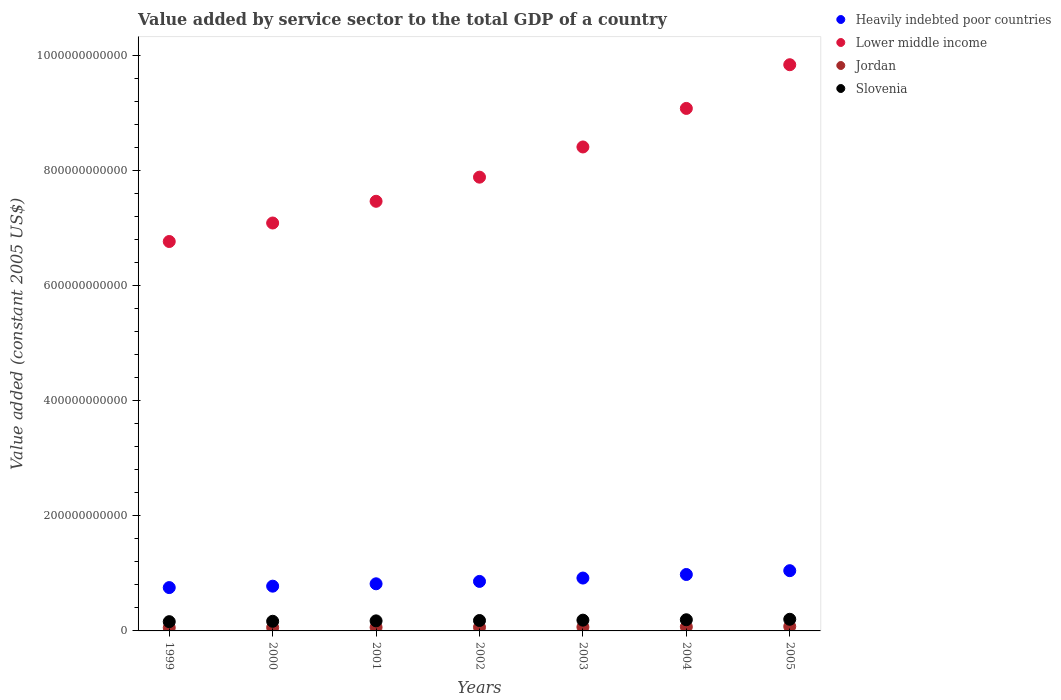What is the value added by service sector in Lower middle income in 2001?
Your response must be concise. 7.46e+11. Across all years, what is the maximum value added by service sector in Jordan?
Provide a short and direct response. 7.67e+09. Across all years, what is the minimum value added by service sector in Jordan?
Make the answer very short. 5.62e+09. In which year was the value added by service sector in Slovenia minimum?
Your answer should be very brief. 1999. What is the total value added by service sector in Jordan in the graph?
Your answer should be compact. 4.54e+1. What is the difference between the value added by service sector in Lower middle income in 1999 and that in 2003?
Provide a short and direct response. -1.64e+11. What is the difference between the value added by service sector in Slovenia in 2004 and the value added by service sector in Heavily indebted poor countries in 2000?
Provide a succinct answer. -5.84e+1. What is the average value added by service sector in Heavily indebted poor countries per year?
Ensure brevity in your answer.  8.79e+1. In the year 1999, what is the difference between the value added by service sector in Jordan and value added by service sector in Lower middle income?
Provide a succinct answer. -6.71e+11. What is the ratio of the value added by service sector in Jordan in 2000 to that in 2004?
Ensure brevity in your answer.  0.83. Is the difference between the value added by service sector in Jordan in 2002 and 2005 greater than the difference between the value added by service sector in Lower middle income in 2002 and 2005?
Keep it short and to the point. Yes. What is the difference between the highest and the second highest value added by service sector in Heavily indebted poor countries?
Offer a terse response. 6.63e+09. What is the difference between the highest and the lowest value added by service sector in Jordan?
Make the answer very short. 2.05e+09. In how many years, is the value added by service sector in Heavily indebted poor countries greater than the average value added by service sector in Heavily indebted poor countries taken over all years?
Your response must be concise. 3. Does the value added by service sector in Slovenia monotonically increase over the years?
Make the answer very short. Yes. Is the value added by service sector in Lower middle income strictly less than the value added by service sector in Slovenia over the years?
Your answer should be compact. No. How many years are there in the graph?
Your answer should be compact. 7. What is the difference between two consecutive major ticks on the Y-axis?
Provide a succinct answer. 2.00e+11. Are the values on the major ticks of Y-axis written in scientific E-notation?
Provide a short and direct response. No. Does the graph contain grids?
Offer a very short reply. No. How many legend labels are there?
Offer a very short reply. 4. How are the legend labels stacked?
Give a very brief answer. Vertical. What is the title of the graph?
Your answer should be compact. Value added by service sector to the total GDP of a country. What is the label or title of the X-axis?
Keep it short and to the point. Years. What is the label or title of the Y-axis?
Your response must be concise. Value added (constant 2005 US$). What is the Value added (constant 2005 US$) of Heavily indebted poor countries in 1999?
Your answer should be very brief. 7.53e+1. What is the Value added (constant 2005 US$) in Lower middle income in 1999?
Your answer should be compact. 6.77e+11. What is the Value added (constant 2005 US$) of Jordan in 1999?
Keep it short and to the point. 5.62e+09. What is the Value added (constant 2005 US$) in Slovenia in 1999?
Make the answer very short. 1.61e+1. What is the Value added (constant 2005 US$) in Heavily indebted poor countries in 2000?
Ensure brevity in your answer.  7.78e+1. What is the Value added (constant 2005 US$) in Lower middle income in 2000?
Keep it short and to the point. 7.09e+11. What is the Value added (constant 2005 US$) in Jordan in 2000?
Offer a very short reply. 5.90e+09. What is the Value added (constant 2005 US$) in Slovenia in 2000?
Provide a short and direct response. 1.68e+1. What is the Value added (constant 2005 US$) in Heavily indebted poor countries in 2001?
Offer a terse response. 8.19e+1. What is the Value added (constant 2005 US$) in Lower middle income in 2001?
Your answer should be very brief. 7.46e+11. What is the Value added (constant 2005 US$) of Jordan in 2001?
Your response must be concise. 6.19e+09. What is the Value added (constant 2005 US$) in Slovenia in 2001?
Your answer should be very brief. 1.75e+1. What is the Value added (constant 2005 US$) in Heavily indebted poor countries in 2002?
Your response must be concise. 8.60e+1. What is the Value added (constant 2005 US$) in Lower middle income in 2002?
Your answer should be compact. 7.88e+11. What is the Value added (constant 2005 US$) in Jordan in 2002?
Offer a very short reply. 6.33e+09. What is the Value added (constant 2005 US$) of Slovenia in 2002?
Make the answer very short. 1.81e+1. What is the Value added (constant 2005 US$) in Heavily indebted poor countries in 2003?
Ensure brevity in your answer.  9.19e+1. What is the Value added (constant 2005 US$) in Lower middle income in 2003?
Keep it short and to the point. 8.41e+11. What is the Value added (constant 2005 US$) in Jordan in 2003?
Offer a terse response. 6.64e+09. What is the Value added (constant 2005 US$) of Slovenia in 2003?
Your response must be concise. 1.87e+1. What is the Value added (constant 2005 US$) in Heavily indebted poor countries in 2004?
Your answer should be very brief. 9.80e+1. What is the Value added (constant 2005 US$) in Lower middle income in 2004?
Offer a very short reply. 9.08e+11. What is the Value added (constant 2005 US$) of Jordan in 2004?
Your answer should be very brief. 7.09e+09. What is the Value added (constant 2005 US$) of Slovenia in 2004?
Your response must be concise. 1.94e+1. What is the Value added (constant 2005 US$) of Heavily indebted poor countries in 2005?
Your answer should be compact. 1.05e+11. What is the Value added (constant 2005 US$) of Lower middle income in 2005?
Provide a short and direct response. 9.84e+11. What is the Value added (constant 2005 US$) of Jordan in 2005?
Offer a very short reply. 7.67e+09. What is the Value added (constant 2005 US$) of Slovenia in 2005?
Provide a short and direct response. 2.02e+1. Across all years, what is the maximum Value added (constant 2005 US$) in Heavily indebted poor countries?
Ensure brevity in your answer.  1.05e+11. Across all years, what is the maximum Value added (constant 2005 US$) of Lower middle income?
Your answer should be compact. 9.84e+11. Across all years, what is the maximum Value added (constant 2005 US$) in Jordan?
Ensure brevity in your answer.  7.67e+09. Across all years, what is the maximum Value added (constant 2005 US$) of Slovenia?
Provide a succinct answer. 2.02e+1. Across all years, what is the minimum Value added (constant 2005 US$) of Heavily indebted poor countries?
Offer a terse response. 7.53e+1. Across all years, what is the minimum Value added (constant 2005 US$) of Lower middle income?
Give a very brief answer. 6.77e+11. Across all years, what is the minimum Value added (constant 2005 US$) of Jordan?
Offer a terse response. 5.62e+09. Across all years, what is the minimum Value added (constant 2005 US$) of Slovenia?
Make the answer very short. 1.61e+1. What is the total Value added (constant 2005 US$) in Heavily indebted poor countries in the graph?
Ensure brevity in your answer.  6.15e+11. What is the total Value added (constant 2005 US$) of Lower middle income in the graph?
Ensure brevity in your answer.  5.65e+12. What is the total Value added (constant 2005 US$) of Jordan in the graph?
Your answer should be compact. 4.54e+1. What is the total Value added (constant 2005 US$) in Slovenia in the graph?
Provide a succinct answer. 1.27e+11. What is the difference between the Value added (constant 2005 US$) of Heavily indebted poor countries in 1999 and that in 2000?
Offer a very short reply. -2.46e+09. What is the difference between the Value added (constant 2005 US$) of Lower middle income in 1999 and that in 2000?
Provide a short and direct response. -3.21e+1. What is the difference between the Value added (constant 2005 US$) of Jordan in 1999 and that in 2000?
Provide a short and direct response. -2.83e+08. What is the difference between the Value added (constant 2005 US$) of Slovenia in 1999 and that in 2000?
Provide a short and direct response. -6.56e+08. What is the difference between the Value added (constant 2005 US$) of Heavily indebted poor countries in 1999 and that in 2001?
Provide a short and direct response. -6.57e+09. What is the difference between the Value added (constant 2005 US$) in Lower middle income in 1999 and that in 2001?
Your answer should be compact. -6.99e+1. What is the difference between the Value added (constant 2005 US$) in Jordan in 1999 and that in 2001?
Offer a very short reply. -5.71e+08. What is the difference between the Value added (constant 2005 US$) in Slovenia in 1999 and that in 2001?
Provide a succinct answer. -1.37e+09. What is the difference between the Value added (constant 2005 US$) in Heavily indebted poor countries in 1999 and that in 2002?
Provide a short and direct response. -1.07e+1. What is the difference between the Value added (constant 2005 US$) in Lower middle income in 1999 and that in 2002?
Ensure brevity in your answer.  -1.12e+11. What is the difference between the Value added (constant 2005 US$) of Jordan in 1999 and that in 2002?
Your answer should be compact. -7.13e+08. What is the difference between the Value added (constant 2005 US$) of Slovenia in 1999 and that in 2002?
Keep it short and to the point. -1.99e+09. What is the difference between the Value added (constant 2005 US$) in Heavily indebted poor countries in 1999 and that in 2003?
Offer a very short reply. -1.66e+1. What is the difference between the Value added (constant 2005 US$) of Lower middle income in 1999 and that in 2003?
Your response must be concise. -1.64e+11. What is the difference between the Value added (constant 2005 US$) in Jordan in 1999 and that in 2003?
Offer a very short reply. -1.03e+09. What is the difference between the Value added (constant 2005 US$) in Slovenia in 1999 and that in 2003?
Give a very brief answer. -2.61e+09. What is the difference between the Value added (constant 2005 US$) in Heavily indebted poor countries in 1999 and that in 2004?
Make the answer very short. -2.27e+1. What is the difference between the Value added (constant 2005 US$) of Lower middle income in 1999 and that in 2004?
Give a very brief answer. -2.31e+11. What is the difference between the Value added (constant 2005 US$) in Jordan in 1999 and that in 2004?
Ensure brevity in your answer.  -1.47e+09. What is the difference between the Value added (constant 2005 US$) in Slovenia in 1999 and that in 2004?
Make the answer very short. -3.30e+09. What is the difference between the Value added (constant 2005 US$) in Heavily indebted poor countries in 1999 and that in 2005?
Give a very brief answer. -2.94e+1. What is the difference between the Value added (constant 2005 US$) of Lower middle income in 1999 and that in 2005?
Make the answer very short. -3.07e+11. What is the difference between the Value added (constant 2005 US$) in Jordan in 1999 and that in 2005?
Give a very brief answer. -2.05e+09. What is the difference between the Value added (constant 2005 US$) of Slovenia in 1999 and that in 2005?
Ensure brevity in your answer.  -4.13e+09. What is the difference between the Value added (constant 2005 US$) in Heavily indebted poor countries in 2000 and that in 2001?
Make the answer very short. -4.12e+09. What is the difference between the Value added (constant 2005 US$) of Lower middle income in 2000 and that in 2001?
Provide a succinct answer. -3.77e+1. What is the difference between the Value added (constant 2005 US$) of Jordan in 2000 and that in 2001?
Provide a short and direct response. -2.88e+08. What is the difference between the Value added (constant 2005 US$) of Slovenia in 2000 and that in 2001?
Your response must be concise. -7.09e+08. What is the difference between the Value added (constant 2005 US$) in Heavily indebted poor countries in 2000 and that in 2002?
Keep it short and to the point. -8.27e+09. What is the difference between the Value added (constant 2005 US$) of Lower middle income in 2000 and that in 2002?
Provide a short and direct response. -7.96e+1. What is the difference between the Value added (constant 2005 US$) of Jordan in 2000 and that in 2002?
Provide a short and direct response. -4.30e+08. What is the difference between the Value added (constant 2005 US$) of Slovenia in 2000 and that in 2002?
Your answer should be compact. -1.33e+09. What is the difference between the Value added (constant 2005 US$) in Heavily indebted poor countries in 2000 and that in 2003?
Make the answer very short. -1.41e+1. What is the difference between the Value added (constant 2005 US$) in Lower middle income in 2000 and that in 2003?
Keep it short and to the point. -1.32e+11. What is the difference between the Value added (constant 2005 US$) of Jordan in 2000 and that in 2003?
Offer a very short reply. -7.44e+08. What is the difference between the Value added (constant 2005 US$) in Slovenia in 2000 and that in 2003?
Your answer should be compact. -1.95e+09. What is the difference between the Value added (constant 2005 US$) in Heavily indebted poor countries in 2000 and that in 2004?
Offer a very short reply. -2.03e+1. What is the difference between the Value added (constant 2005 US$) of Lower middle income in 2000 and that in 2004?
Offer a terse response. -1.99e+11. What is the difference between the Value added (constant 2005 US$) in Jordan in 2000 and that in 2004?
Your answer should be very brief. -1.19e+09. What is the difference between the Value added (constant 2005 US$) in Slovenia in 2000 and that in 2004?
Ensure brevity in your answer.  -2.65e+09. What is the difference between the Value added (constant 2005 US$) of Heavily indebted poor countries in 2000 and that in 2005?
Your response must be concise. -2.69e+1. What is the difference between the Value added (constant 2005 US$) of Lower middle income in 2000 and that in 2005?
Keep it short and to the point. -2.75e+11. What is the difference between the Value added (constant 2005 US$) of Jordan in 2000 and that in 2005?
Your answer should be very brief. -1.77e+09. What is the difference between the Value added (constant 2005 US$) of Slovenia in 2000 and that in 2005?
Provide a succinct answer. -3.47e+09. What is the difference between the Value added (constant 2005 US$) of Heavily indebted poor countries in 2001 and that in 2002?
Your answer should be compact. -4.15e+09. What is the difference between the Value added (constant 2005 US$) of Lower middle income in 2001 and that in 2002?
Offer a very short reply. -4.19e+1. What is the difference between the Value added (constant 2005 US$) of Jordan in 2001 and that in 2002?
Your answer should be very brief. -1.42e+08. What is the difference between the Value added (constant 2005 US$) of Slovenia in 2001 and that in 2002?
Your response must be concise. -6.23e+08. What is the difference between the Value added (constant 2005 US$) in Heavily indebted poor countries in 2001 and that in 2003?
Your response must be concise. -9.98e+09. What is the difference between the Value added (constant 2005 US$) of Lower middle income in 2001 and that in 2003?
Make the answer very short. -9.44e+1. What is the difference between the Value added (constant 2005 US$) in Jordan in 2001 and that in 2003?
Offer a very short reply. -4.56e+08. What is the difference between the Value added (constant 2005 US$) in Slovenia in 2001 and that in 2003?
Provide a succinct answer. -1.24e+09. What is the difference between the Value added (constant 2005 US$) in Heavily indebted poor countries in 2001 and that in 2004?
Provide a succinct answer. -1.62e+1. What is the difference between the Value added (constant 2005 US$) of Lower middle income in 2001 and that in 2004?
Ensure brevity in your answer.  -1.61e+11. What is the difference between the Value added (constant 2005 US$) in Jordan in 2001 and that in 2004?
Your response must be concise. -8.99e+08. What is the difference between the Value added (constant 2005 US$) of Slovenia in 2001 and that in 2004?
Provide a short and direct response. -1.94e+09. What is the difference between the Value added (constant 2005 US$) in Heavily indebted poor countries in 2001 and that in 2005?
Your answer should be compact. -2.28e+1. What is the difference between the Value added (constant 2005 US$) of Lower middle income in 2001 and that in 2005?
Make the answer very short. -2.37e+11. What is the difference between the Value added (constant 2005 US$) in Jordan in 2001 and that in 2005?
Provide a succinct answer. -1.48e+09. What is the difference between the Value added (constant 2005 US$) of Slovenia in 2001 and that in 2005?
Your answer should be very brief. -2.76e+09. What is the difference between the Value added (constant 2005 US$) in Heavily indebted poor countries in 2002 and that in 2003?
Provide a short and direct response. -5.83e+09. What is the difference between the Value added (constant 2005 US$) of Lower middle income in 2002 and that in 2003?
Offer a very short reply. -5.25e+1. What is the difference between the Value added (constant 2005 US$) of Jordan in 2002 and that in 2003?
Give a very brief answer. -3.14e+08. What is the difference between the Value added (constant 2005 US$) in Slovenia in 2002 and that in 2003?
Keep it short and to the point. -6.22e+08. What is the difference between the Value added (constant 2005 US$) of Heavily indebted poor countries in 2002 and that in 2004?
Provide a short and direct response. -1.20e+1. What is the difference between the Value added (constant 2005 US$) of Lower middle income in 2002 and that in 2004?
Provide a succinct answer. -1.19e+11. What is the difference between the Value added (constant 2005 US$) of Jordan in 2002 and that in 2004?
Give a very brief answer. -7.56e+08. What is the difference between the Value added (constant 2005 US$) of Slovenia in 2002 and that in 2004?
Your answer should be very brief. -1.32e+09. What is the difference between the Value added (constant 2005 US$) of Heavily indebted poor countries in 2002 and that in 2005?
Provide a succinct answer. -1.86e+1. What is the difference between the Value added (constant 2005 US$) in Lower middle income in 2002 and that in 2005?
Ensure brevity in your answer.  -1.95e+11. What is the difference between the Value added (constant 2005 US$) in Jordan in 2002 and that in 2005?
Ensure brevity in your answer.  -1.34e+09. What is the difference between the Value added (constant 2005 US$) of Slovenia in 2002 and that in 2005?
Provide a succinct answer. -2.14e+09. What is the difference between the Value added (constant 2005 US$) in Heavily indebted poor countries in 2003 and that in 2004?
Offer a very short reply. -6.18e+09. What is the difference between the Value added (constant 2005 US$) in Lower middle income in 2003 and that in 2004?
Keep it short and to the point. -6.70e+1. What is the difference between the Value added (constant 2005 US$) of Jordan in 2003 and that in 2004?
Ensure brevity in your answer.  -4.42e+08. What is the difference between the Value added (constant 2005 US$) of Slovenia in 2003 and that in 2004?
Ensure brevity in your answer.  -6.94e+08. What is the difference between the Value added (constant 2005 US$) of Heavily indebted poor countries in 2003 and that in 2005?
Ensure brevity in your answer.  -1.28e+1. What is the difference between the Value added (constant 2005 US$) in Lower middle income in 2003 and that in 2005?
Provide a short and direct response. -1.43e+11. What is the difference between the Value added (constant 2005 US$) in Jordan in 2003 and that in 2005?
Your answer should be very brief. -1.03e+09. What is the difference between the Value added (constant 2005 US$) in Slovenia in 2003 and that in 2005?
Your answer should be very brief. -1.52e+09. What is the difference between the Value added (constant 2005 US$) in Heavily indebted poor countries in 2004 and that in 2005?
Offer a very short reply. -6.63e+09. What is the difference between the Value added (constant 2005 US$) in Lower middle income in 2004 and that in 2005?
Offer a very short reply. -7.59e+1. What is the difference between the Value added (constant 2005 US$) in Jordan in 2004 and that in 2005?
Give a very brief answer. -5.85e+08. What is the difference between the Value added (constant 2005 US$) in Slovenia in 2004 and that in 2005?
Provide a succinct answer. -8.23e+08. What is the difference between the Value added (constant 2005 US$) in Heavily indebted poor countries in 1999 and the Value added (constant 2005 US$) in Lower middle income in 2000?
Your answer should be very brief. -6.33e+11. What is the difference between the Value added (constant 2005 US$) in Heavily indebted poor countries in 1999 and the Value added (constant 2005 US$) in Jordan in 2000?
Offer a terse response. 6.94e+1. What is the difference between the Value added (constant 2005 US$) of Heavily indebted poor countries in 1999 and the Value added (constant 2005 US$) of Slovenia in 2000?
Ensure brevity in your answer.  5.85e+1. What is the difference between the Value added (constant 2005 US$) in Lower middle income in 1999 and the Value added (constant 2005 US$) in Jordan in 2000?
Give a very brief answer. 6.71e+11. What is the difference between the Value added (constant 2005 US$) of Lower middle income in 1999 and the Value added (constant 2005 US$) of Slovenia in 2000?
Your response must be concise. 6.60e+11. What is the difference between the Value added (constant 2005 US$) in Jordan in 1999 and the Value added (constant 2005 US$) in Slovenia in 2000?
Provide a succinct answer. -1.11e+1. What is the difference between the Value added (constant 2005 US$) in Heavily indebted poor countries in 1999 and the Value added (constant 2005 US$) in Lower middle income in 2001?
Your answer should be very brief. -6.71e+11. What is the difference between the Value added (constant 2005 US$) of Heavily indebted poor countries in 1999 and the Value added (constant 2005 US$) of Jordan in 2001?
Ensure brevity in your answer.  6.91e+1. What is the difference between the Value added (constant 2005 US$) of Heavily indebted poor countries in 1999 and the Value added (constant 2005 US$) of Slovenia in 2001?
Offer a very short reply. 5.78e+1. What is the difference between the Value added (constant 2005 US$) in Lower middle income in 1999 and the Value added (constant 2005 US$) in Jordan in 2001?
Ensure brevity in your answer.  6.70e+11. What is the difference between the Value added (constant 2005 US$) of Lower middle income in 1999 and the Value added (constant 2005 US$) of Slovenia in 2001?
Keep it short and to the point. 6.59e+11. What is the difference between the Value added (constant 2005 US$) of Jordan in 1999 and the Value added (constant 2005 US$) of Slovenia in 2001?
Your response must be concise. -1.18e+1. What is the difference between the Value added (constant 2005 US$) in Heavily indebted poor countries in 1999 and the Value added (constant 2005 US$) in Lower middle income in 2002?
Give a very brief answer. -7.13e+11. What is the difference between the Value added (constant 2005 US$) in Heavily indebted poor countries in 1999 and the Value added (constant 2005 US$) in Jordan in 2002?
Give a very brief answer. 6.90e+1. What is the difference between the Value added (constant 2005 US$) of Heavily indebted poor countries in 1999 and the Value added (constant 2005 US$) of Slovenia in 2002?
Give a very brief answer. 5.72e+1. What is the difference between the Value added (constant 2005 US$) of Lower middle income in 1999 and the Value added (constant 2005 US$) of Jordan in 2002?
Offer a terse response. 6.70e+11. What is the difference between the Value added (constant 2005 US$) in Lower middle income in 1999 and the Value added (constant 2005 US$) in Slovenia in 2002?
Give a very brief answer. 6.58e+11. What is the difference between the Value added (constant 2005 US$) of Jordan in 1999 and the Value added (constant 2005 US$) of Slovenia in 2002?
Your answer should be compact. -1.25e+1. What is the difference between the Value added (constant 2005 US$) of Heavily indebted poor countries in 1999 and the Value added (constant 2005 US$) of Lower middle income in 2003?
Your answer should be very brief. -7.66e+11. What is the difference between the Value added (constant 2005 US$) in Heavily indebted poor countries in 1999 and the Value added (constant 2005 US$) in Jordan in 2003?
Ensure brevity in your answer.  6.87e+1. What is the difference between the Value added (constant 2005 US$) in Heavily indebted poor countries in 1999 and the Value added (constant 2005 US$) in Slovenia in 2003?
Offer a terse response. 5.66e+1. What is the difference between the Value added (constant 2005 US$) of Lower middle income in 1999 and the Value added (constant 2005 US$) of Jordan in 2003?
Offer a terse response. 6.70e+11. What is the difference between the Value added (constant 2005 US$) of Lower middle income in 1999 and the Value added (constant 2005 US$) of Slovenia in 2003?
Offer a very short reply. 6.58e+11. What is the difference between the Value added (constant 2005 US$) of Jordan in 1999 and the Value added (constant 2005 US$) of Slovenia in 2003?
Your answer should be very brief. -1.31e+1. What is the difference between the Value added (constant 2005 US$) in Heavily indebted poor countries in 1999 and the Value added (constant 2005 US$) in Lower middle income in 2004?
Ensure brevity in your answer.  -8.32e+11. What is the difference between the Value added (constant 2005 US$) in Heavily indebted poor countries in 1999 and the Value added (constant 2005 US$) in Jordan in 2004?
Your answer should be very brief. 6.82e+1. What is the difference between the Value added (constant 2005 US$) of Heavily indebted poor countries in 1999 and the Value added (constant 2005 US$) of Slovenia in 2004?
Offer a terse response. 5.59e+1. What is the difference between the Value added (constant 2005 US$) of Lower middle income in 1999 and the Value added (constant 2005 US$) of Jordan in 2004?
Your answer should be compact. 6.69e+11. What is the difference between the Value added (constant 2005 US$) of Lower middle income in 1999 and the Value added (constant 2005 US$) of Slovenia in 2004?
Provide a short and direct response. 6.57e+11. What is the difference between the Value added (constant 2005 US$) of Jordan in 1999 and the Value added (constant 2005 US$) of Slovenia in 2004?
Provide a short and direct response. -1.38e+1. What is the difference between the Value added (constant 2005 US$) of Heavily indebted poor countries in 1999 and the Value added (constant 2005 US$) of Lower middle income in 2005?
Provide a short and direct response. -9.08e+11. What is the difference between the Value added (constant 2005 US$) in Heavily indebted poor countries in 1999 and the Value added (constant 2005 US$) in Jordan in 2005?
Provide a short and direct response. 6.76e+1. What is the difference between the Value added (constant 2005 US$) in Heavily indebted poor countries in 1999 and the Value added (constant 2005 US$) in Slovenia in 2005?
Offer a terse response. 5.51e+1. What is the difference between the Value added (constant 2005 US$) of Lower middle income in 1999 and the Value added (constant 2005 US$) of Jordan in 2005?
Keep it short and to the point. 6.69e+11. What is the difference between the Value added (constant 2005 US$) of Lower middle income in 1999 and the Value added (constant 2005 US$) of Slovenia in 2005?
Ensure brevity in your answer.  6.56e+11. What is the difference between the Value added (constant 2005 US$) in Jordan in 1999 and the Value added (constant 2005 US$) in Slovenia in 2005?
Keep it short and to the point. -1.46e+1. What is the difference between the Value added (constant 2005 US$) of Heavily indebted poor countries in 2000 and the Value added (constant 2005 US$) of Lower middle income in 2001?
Ensure brevity in your answer.  -6.69e+11. What is the difference between the Value added (constant 2005 US$) of Heavily indebted poor countries in 2000 and the Value added (constant 2005 US$) of Jordan in 2001?
Keep it short and to the point. 7.16e+1. What is the difference between the Value added (constant 2005 US$) of Heavily indebted poor countries in 2000 and the Value added (constant 2005 US$) of Slovenia in 2001?
Offer a very short reply. 6.03e+1. What is the difference between the Value added (constant 2005 US$) of Lower middle income in 2000 and the Value added (constant 2005 US$) of Jordan in 2001?
Give a very brief answer. 7.03e+11. What is the difference between the Value added (constant 2005 US$) of Lower middle income in 2000 and the Value added (constant 2005 US$) of Slovenia in 2001?
Ensure brevity in your answer.  6.91e+11. What is the difference between the Value added (constant 2005 US$) of Jordan in 2000 and the Value added (constant 2005 US$) of Slovenia in 2001?
Provide a succinct answer. -1.16e+1. What is the difference between the Value added (constant 2005 US$) of Heavily indebted poor countries in 2000 and the Value added (constant 2005 US$) of Lower middle income in 2002?
Give a very brief answer. -7.11e+11. What is the difference between the Value added (constant 2005 US$) in Heavily indebted poor countries in 2000 and the Value added (constant 2005 US$) in Jordan in 2002?
Keep it short and to the point. 7.14e+1. What is the difference between the Value added (constant 2005 US$) of Heavily indebted poor countries in 2000 and the Value added (constant 2005 US$) of Slovenia in 2002?
Offer a terse response. 5.97e+1. What is the difference between the Value added (constant 2005 US$) in Lower middle income in 2000 and the Value added (constant 2005 US$) in Jordan in 2002?
Keep it short and to the point. 7.02e+11. What is the difference between the Value added (constant 2005 US$) of Lower middle income in 2000 and the Value added (constant 2005 US$) of Slovenia in 2002?
Provide a succinct answer. 6.91e+11. What is the difference between the Value added (constant 2005 US$) in Jordan in 2000 and the Value added (constant 2005 US$) in Slovenia in 2002?
Keep it short and to the point. -1.22e+1. What is the difference between the Value added (constant 2005 US$) of Heavily indebted poor countries in 2000 and the Value added (constant 2005 US$) of Lower middle income in 2003?
Provide a succinct answer. -7.63e+11. What is the difference between the Value added (constant 2005 US$) in Heavily indebted poor countries in 2000 and the Value added (constant 2005 US$) in Jordan in 2003?
Offer a terse response. 7.11e+1. What is the difference between the Value added (constant 2005 US$) of Heavily indebted poor countries in 2000 and the Value added (constant 2005 US$) of Slovenia in 2003?
Your response must be concise. 5.90e+1. What is the difference between the Value added (constant 2005 US$) in Lower middle income in 2000 and the Value added (constant 2005 US$) in Jordan in 2003?
Give a very brief answer. 7.02e+11. What is the difference between the Value added (constant 2005 US$) in Lower middle income in 2000 and the Value added (constant 2005 US$) in Slovenia in 2003?
Give a very brief answer. 6.90e+11. What is the difference between the Value added (constant 2005 US$) in Jordan in 2000 and the Value added (constant 2005 US$) in Slovenia in 2003?
Offer a very short reply. -1.28e+1. What is the difference between the Value added (constant 2005 US$) in Heavily indebted poor countries in 2000 and the Value added (constant 2005 US$) in Lower middle income in 2004?
Provide a short and direct response. -8.30e+11. What is the difference between the Value added (constant 2005 US$) of Heavily indebted poor countries in 2000 and the Value added (constant 2005 US$) of Jordan in 2004?
Keep it short and to the point. 7.07e+1. What is the difference between the Value added (constant 2005 US$) in Heavily indebted poor countries in 2000 and the Value added (constant 2005 US$) in Slovenia in 2004?
Your answer should be very brief. 5.84e+1. What is the difference between the Value added (constant 2005 US$) in Lower middle income in 2000 and the Value added (constant 2005 US$) in Jordan in 2004?
Offer a very short reply. 7.02e+11. What is the difference between the Value added (constant 2005 US$) in Lower middle income in 2000 and the Value added (constant 2005 US$) in Slovenia in 2004?
Your answer should be very brief. 6.89e+11. What is the difference between the Value added (constant 2005 US$) of Jordan in 2000 and the Value added (constant 2005 US$) of Slovenia in 2004?
Your answer should be compact. -1.35e+1. What is the difference between the Value added (constant 2005 US$) of Heavily indebted poor countries in 2000 and the Value added (constant 2005 US$) of Lower middle income in 2005?
Give a very brief answer. -9.06e+11. What is the difference between the Value added (constant 2005 US$) in Heavily indebted poor countries in 2000 and the Value added (constant 2005 US$) in Jordan in 2005?
Give a very brief answer. 7.01e+1. What is the difference between the Value added (constant 2005 US$) in Heavily indebted poor countries in 2000 and the Value added (constant 2005 US$) in Slovenia in 2005?
Provide a succinct answer. 5.75e+1. What is the difference between the Value added (constant 2005 US$) of Lower middle income in 2000 and the Value added (constant 2005 US$) of Jordan in 2005?
Your response must be concise. 7.01e+11. What is the difference between the Value added (constant 2005 US$) of Lower middle income in 2000 and the Value added (constant 2005 US$) of Slovenia in 2005?
Offer a terse response. 6.88e+11. What is the difference between the Value added (constant 2005 US$) in Jordan in 2000 and the Value added (constant 2005 US$) in Slovenia in 2005?
Offer a very short reply. -1.43e+1. What is the difference between the Value added (constant 2005 US$) in Heavily indebted poor countries in 2001 and the Value added (constant 2005 US$) in Lower middle income in 2002?
Keep it short and to the point. -7.06e+11. What is the difference between the Value added (constant 2005 US$) in Heavily indebted poor countries in 2001 and the Value added (constant 2005 US$) in Jordan in 2002?
Give a very brief answer. 7.55e+1. What is the difference between the Value added (constant 2005 US$) in Heavily indebted poor countries in 2001 and the Value added (constant 2005 US$) in Slovenia in 2002?
Keep it short and to the point. 6.38e+1. What is the difference between the Value added (constant 2005 US$) in Lower middle income in 2001 and the Value added (constant 2005 US$) in Jordan in 2002?
Provide a short and direct response. 7.40e+11. What is the difference between the Value added (constant 2005 US$) of Lower middle income in 2001 and the Value added (constant 2005 US$) of Slovenia in 2002?
Give a very brief answer. 7.28e+11. What is the difference between the Value added (constant 2005 US$) of Jordan in 2001 and the Value added (constant 2005 US$) of Slovenia in 2002?
Make the answer very short. -1.19e+1. What is the difference between the Value added (constant 2005 US$) in Heavily indebted poor countries in 2001 and the Value added (constant 2005 US$) in Lower middle income in 2003?
Your answer should be compact. -7.59e+11. What is the difference between the Value added (constant 2005 US$) of Heavily indebted poor countries in 2001 and the Value added (constant 2005 US$) of Jordan in 2003?
Give a very brief answer. 7.52e+1. What is the difference between the Value added (constant 2005 US$) in Heavily indebted poor countries in 2001 and the Value added (constant 2005 US$) in Slovenia in 2003?
Your response must be concise. 6.32e+1. What is the difference between the Value added (constant 2005 US$) in Lower middle income in 2001 and the Value added (constant 2005 US$) in Jordan in 2003?
Give a very brief answer. 7.40e+11. What is the difference between the Value added (constant 2005 US$) in Lower middle income in 2001 and the Value added (constant 2005 US$) in Slovenia in 2003?
Provide a short and direct response. 7.28e+11. What is the difference between the Value added (constant 2005 US$) of Jordan in 2001 and the Value added (constant 2005 US$) of Slovenia in 2003?
Your answer should be compact. -1.25e+1. What is the difference between the Value added (constant 2005 US$) of Heavily indebted poor countries in 2001 and the Value added (constant 2005 US$) of Lower middle income in 2004?
Offer a very short reply. -8.26e+11. What is the difference between the Value added (constant 2005 US$) of Heavily indebted poor countries in 2001 and the Value added (constant 2005 US$) of Jordan in 2004?
Keep it short and to the point. 7.48e+1. What is the difference between the Value added (constant 2005 US$) of Heavily indebted poor countries in 2001 and the Value added (constant 2005 US$) of Slovenia in 2004?
Ensure brevity in your answer.  6.25e+1. What is the difference between the Value added (constant 2005 US$) of Lower middle income in 2001 and the Value added (constant 2005 US$) of Jordan in 2004?
Give a very brief answer. 7.39e+11. What is the difference between the Value added (constant 2005 US$) of Lower middle income in 2001 and the Value added (constant 2005 US$) of Slovenia in 2004?
Your response must be concise. 7.27e+11. What is the difference between the Value added (constant 2005 US$) in Jordan in 2001 and the Value added (constant 2005 US$) in Slovenia in 2004?
Keep it short and to the point. -1.32e+1. What is the difference between the Value added (constant 2005 US$) in Heavily indebted poor countries in 2001 and the Value added (constant 2005 US$) in Lower middle income in 2005?
Your answer should be very brief. -9.02e+11. What is the difference between the Value added (constant 2005 US$) of Heavily indebted poor countries in 2001 and the Value added (constant 2005 US$) of Jordan in 2005?
Provide a succinct answer. 7.42e+1. What is the difference between the Value added (constant 2005 US$) of Heavily indebted poor countries in 2001 and the Value added (constant 2005 US$) of Slovenia in 2005?
Offer a terse response. 6.16e+1. What is the difference between the Value added (constant 2005 US$) in Lower middle income in 2001 and the Value added (constant 2005 US$) in Jordan in 2005?
Your response must be concise. 7.39e+11. What is the difference between the Value added (constant 2005 US$) in Lower middle income in 2001 and the Value added (constant 2005 US$) in Slovenia in 2005?
Offer a terse response. 7.26e+11. What is the difference between the Value added (constant 2005 US$) of Jordan in 2001 and the Value added (constant 2005 US$) of Slovenia in 2005?
Offer a terse response. -1.40e+1. What is the difference between the Value added (constant 2005 US$) in Heavily indebted poor countries in 2002 and the Value added (constant 2005 US$) in Lower middle income in 2003?
Make the answer very short. -7.55e+11. What is the difference between the Value added (constant 2005 US$) of Heavily indebted poor countries in 2002 and the Value added (constant 2005 US$) of Jordan in 2003?
Provide a short and direct response. 7.94e+1. What is the difference between the Value added (constant 2005 US$) in Heavily indebted poor countries in 2002 and the Value added (constant 2005 US$) in Slovenia in 2003?
Make the answer very short. 6.73e+1. What is the difference between the Value added (constant 2005 US$) in Lower middle income in 2002 and the Value added (constant 2005 US$) in Jordan in 2003?
Provide a short and direct response. 7.82e+11. What is the difference between the Value added (constant 2005 US$) in Lower middle income in 2002 and the Value added (constant 2005 US$) in Slovenia in 2003?
Ensure brevity in your answer.  7.70e+11. What is the difference between the Value added (constant 2005 US$) of Jordan in 2002 and the Value added (constant 2005 US$) of Slovenia in 2003?
Ensure brevity in your answer.  -1.24e+1. What is the difference between the Value added (constant 2005 US$) of Heavily indebted poor countries in 2002 and the Value added (constant 2005 US$) of Lower middle income in 2004?
Make the answer very short. -8.22e+11. What is the difference between the Value added (constant 2005 US$) of Heavily indebted poor countries in 2002 and the Value added (constant 2005 US$) of Jordan in 2004?
Make the answer very short. 7.89e+1. What is the difference between the Value added (constant 2005 US$) of Heavily indebted poor countries in 2002 and the Value added (constant 2005 US$) of Slovenia in 2004?
Give a very brief answer. 6.66e+1. What is the difference between the Value added (constant 2005 US$) of Lower middle income in 2002 and the Value added (constant 2005 US$) of Jordan in 2004?
Give a very brief answer. 7.81e+11. What is the difference between the Value added (constant 2005 US$) in Lower middle income in 2002 and the Value added (constant 2005 US$) in Slovenia in 2004?
Ensure brevity in your answer.  7.69e+11. What is the difference between the Value added (constant 2005 US$) of Jordan in 2002 and the Value added (constant 2005 US$) of Slovenia in 2004?
Ensure brevity in your answer.  -1.31e+1. What is the difference between the Value added (constant 2005 US$) of Heavily indebted poor countries in 2002 and the Value added (constant 2005 US$) of Lower middle income in 2005?
Make the answer very short. -8.98e+11. What is the difference between the Value added (constant 2005 US$) of Heavily indebted poor countries in 2002 and the Value added (constant 2005 US$) of Jordan in 2005?
Offer a very short reply. 7.84e+1. What is the difference between the Value added (constant 2005 US$) in Heavily indebted poor countries in 2002 and the Value added (constant 2005 US$) in Slovenia in 2005?
Your answer should be very brief. 6.58e+1. What is the difference between the Value added (constant 2005 US$) of Lower middle income in 2002 and the Value added (constant 2005 US$) of Jordan in 2005?
Your response must be concise. 7.81e+11. What is the difference between the Value added (constant 2005 US$) of Lower middle income in 2002 and the Value added (constant 2005 US$) of Slovenia in 2005?
Your answer should be very brief. 7.68e+11. What is the difference between the Value added (constant 2005 US$) in Jordan in 2002 and the Value added (constant 2005 US$) in Slovenia in 2005?
Ensure brevity in your answer.  -1.39e+1. What is the difference between the Value added (constant 2005 US$) in Heavily indebted poor countries in 2003 and the Value added (constant 2005 US$) in Lower middle income in 2004?
Offer a terse response. -8.16e+11. What is the difference between the Value added (constant 2005 US$) in Heavily indebted poor countries in 2003 and the Value added (constant 2005 US$) in Jordan in 2004?
Your answer should be very brief. 8.48e+1. What is the difference between the Value added (constant 2005 US$) of Heavily indebted poor countries in 2003 and the Value added (constant 2005 US$) of Slovenia in 2004?
Give a very brief answer. 7.25e+1. What is the difference between the Value added (constant 2005 US$) in Lower middle income in 2003 and the Value added (constant 2005 US$) in Jordan in 2004?
Give a very brief answer. 8.34e+11. What is the difference between the Value added (constant 2005 US$) of Lower middle income in 2003 and the Value added (constant 2005 US$) of Slovenia in 2004?
Your response must be concise. 8.21e+11. What is the difference between the Value added (constant 2005 US$) of Jordan in 2003 and the Value added (constant 2005 US$) of Slovenia in 2004?
Your response must be concise. -1.28e+1. What is the difference between the Value added (constant 2005 US$) of Heavily indebted poor countries in 2003 and the Value added (constant 2005 US$) of Lower middle income in 2005?
Ensure brevity in your answer.  -8.92e+11. What is the difference between the Value added (constant 2005 US$) in Heavily indebted poor countries in 2003 and the Value added (constant 2005 US$) in Jordan in 2005?
Offer a terse response. 8.42e+1. What is the difference between the Value added (constant 2005 US$) in Heavily indebted poor countries in 2003 and the Value added (constant 2005 US$) in Slovenia in 2005?
Offer a very short reply. 7.16e+1. What is the difference between the Value added (constant 2005 US$) of Lower middle income in 2003 and the Value added (constant 2005 US$) of Jordan in 2005?
Provide a succinct answer. 8.33e+11. What is the difference between the Value added (constant 2005 US$) in Lower middle income in 2003 and the Value added (constant 2005 US$) in Slovenia in 2005?
Your response must be concise. 8.21e+11. What is the difference between the Value added (constant 2005 US$) in Jordan in 2003 and the Value added (constant 2005 US$) in Slovenia in 2005?
Offer a terse response. -1.36e+1. What is the difference between the Value added (constant 2005 US$) in Heavily indebted poor countries in 2004 and the Value added (constant 2005 US$) in Lower middle income in 2005?
Keep it short and to the point. -8.86e+11. What is the difference between the Value added (constant 2005 US$) of Heavily indebted poor countries in 2004 and the Value added (constant 2005 US$) of Jordan in 2005?
Your answer should be compact. 9.04e+1. What is the difference between the Value added (constant 2005 US$) of Heavily indebted poor countries in 2004 and the Value added (constant 2005 US$) of Slovenia in 2005?
Make the answer very short. 7.78e+1. What is the difference between the Value added (constant 2005 US$) of Lower middle income in 2004 and the Value added (constant 2005 US$) of Jordan in 2005?
Ensure brevity in your answer.  9.00e+11. What is the difference between the Value added (constant 2005 US$) of Lower middle income in 2004 and the Value added (constant 2005 US$) of Slovenia in 2005?
Offer a terse response. 8.88e+11. What is the difference between the Value added (constant 2005 US$) of Jordan in 2004 and the Value added (constant 2005 US$) of Slovenia in 2005?
Give a very brief answer. -1.31e+1. What is the average Value added (constant 2005 US$) of Heavily indebted poor countries per year?
Keep it short and to the point. 8.79e+1. What is the average Value added (constant 2005 US$) in Lower middle income per year?
Give a very brief answer. 8.07e+11. What is the average Value added (constant 2005 US$) of Jordan per year?
Make the answer very short. 6.49e+09. What is the average Value added (constant 2005 US$) in Slovenia per year?
Provide a short and direct response. 1.81e+1. In the year 1999, what is the difference between the Value added (constant 2005 US$) of Heavily indebted poor countries and Value added (constant 2005 US$) of Lower middle income?
Your response must be concise. -6.01e+11. In the year 1999, what is the difference between the Value added (constant 2005 US$) of Heavily indebted poor countries and Value added (constant 2005 US$) of Jordan?
Offer a very short reply. 6.97e+1. In the year 1999, what is the difference between the Value added (constant 2005 US$) in Heavily indebted poor countries and Value added (constant 2005 US$) in Slovenia?
Provide a short and direct response. 5.92e+1. In the year 1999, what is the difference between the Value added (constant 2005 US$) of Lower middle income and Value added (constant 2005 US$) of Jordan?
Your response must be concise. 6.71e+11. In the year 1999, what is the difference between the Value added (constant 2005 US$) in Lower middle income and Value added (constant 2005 US$) in Slovenia?
Your response must be concise. 6.60e+11. In the year 1999, what is the difference between the Value added (constant 2005 US$) of Jordan and Value added (constant 2005 US$) of Slovenia?
Ensure brevity in your answer.  -1.05e+1. In the year 2000, what is the difference between the Value added (constant 2005 US$) in Heavily indebted poor countries and Value added (constant 2005 US$) in Lower middle income?
Ensure brevity in your answer.  -6.31e+11. In the year 2000, what is the difference between the Value added (constant 2005 US$) of Heavily indebted poor countries and Value added (constant 2005 US$) of Jordan?
Offer a very short reply. 7.19e+1. In the year 2000, what is the difference between the Value added (constant 2005 US$) in Heavily indebted poor countries and Value added (constant 2005 US$) in Slovenia?
Your answer should be compact. 6.10e+1. In the year 2000, what is the difference between the Value added (constant 2005 US$) of Lower middle income and Value added (constant 2005 US$) of Jordan?
Your answer should be very brief. 7.03e+11. In the year 2000, what is the difference between the Value added (constant 2005 US$) in Lower middle income and Value added (constant 2005 US$) in Slovenia?
Your answer should be very brief. 6.92e+11. In the year 2000, what is the difference between the Value added (constant 2005 US$) in Jordan and Value added (constant 2005 US$) in Slovenia?
Keep it short and to the point. -1.09e+1. In the year 2001, what is the difference between the Value added (constant 2005 US$) of Heavily indebted poor countries and Value added (constant 2005 US$) of Lower middle income?
Keep it short and to the point. -6.65e+11. In the year 2001, what is the difference between the Value added (constant 2005 US$) in Heavily indebted poor countries and Value added (constant 2005 US$) in Jordan?
Offer a terse response. 7.57e+1. In the year 2001, what is the difference between the Value added (constant 2005 US$) of Heavily indebted poor countries and Value added (constant 2005 US$) of Slovenia?
Give a very brief answer. 6.44e+1. In the year 2001, what is the difference between the Value added (constant 2005 US$) in Lower middle income and Value added (constant 2005 US$) in Jordan?
Provide a succinct answer. 7.40e+11. In the year 2001, what is the difference between the Value added (constant 2005 US$) of Lower middle income and Value added (constant 2005 US$) of Slovenia?
Your answer should be compact. 7.29e+11. In the year 2001, what is the difference between the Value added (constant 2005 US$) in Jordan and Value added (constant 2005 US$) in Slovenia?
Provide a succinct answer. -1.13e+1. In the year 2002, what is the difference between the Value added (constant 2005 US$) in Heavily indebted poor countries and Value added (constant 2005 US$) in Lower middle income?
Provide a succinct answer. -7.02e+11. In the year 2002, what is the difference between the Value added (constant 2005 US$) in Heavily indebted poor countries and Value added (constant 2005 US$) in Jordan?
Your answer should be very brief. 7.97e+1. In the year 2002, what is the difference between the Value added (constant 2005 US$) of Heavily indebted poor countries and Value added (constant 2005 US$) of Slovenia?
Your answer should be very brief. 6.79e+1. In the year 2002, what is the difference between the Value added (constant 2005 US$) in Lower middle income and Value added (constant 2005 US$) in Jordan?
Give a very brief answer. 7.82e+11. In the year 2002, what is the difference between the Value added (constant 2005 US$) in Lower middle income and Value added (constant 2005 US$) in Slovenia?
Ensure brevity in your answer.  7.70e+11. In the year 2002, what is the difference between the Value added (constant 2005 US$) of Jordan and Value added (constant 2005 US$) of Slovenia?
Make the answer very short. -1.18e+1. In the year 2003, what is the difference between the Value added (constant 2005 US$) in Heavily indebted poor countries and Value added (constant 2005 US$) in Lower middle income?
Provide a short and direct response. -7.49e+11. In the year 2003, what is the difference between the Value added (constant 2005 US$) in Heavily indebted poor countries and Value added (constant 2005 US$) in Jordan?
Keep it short and to the point. 8.52e+1. In the year 2003, what is the difference between the Value added (constant 2005 US$) of Heavily indebted poor countries and Value added (constant 2005 US$) of Slovenia?
Offer a very short reply. 7.31e+1. In the year 2003, what is the difference between the Value added (constant 2005 US$) in Lower middle income and Value added (constant 2005 US$) in Jordan?
Ensure brevity in your answer.  8.34e+11. In the year 2003, what is the difference between the Value added (constant 2005 US$) of Lower middle income and Value added (constant 2005 US$) of Slovenia?
Ensure brevity in your answer.  8.22e+11. In the year 2003, what is the difference between the Value added (constant 2005 US$) of Jordan and Value added (constant 2005 US$) of Slovenia?
Provide a short and direct response. -1.21e+1. In the year 2004, what is the difference between the Value added (constant 2005 US$) of Heavily indebted poor countries and Value added (constant 2005 US$) of Lower middle income?
Your answer should be very brief. -8.10e+11. In the year 2004, what is the difference between the Value added (constant 2005 US$) in Heavily indebted poor countries and Value added (constant 2005 US$) in Jordan?
Make the answer very short. 9.09e+1. In the year 2004, what is the difference between the Value added (constant 2005 US$) in Heavily indebted poor countries and Value added (constant 2005 US$) in Slovenia?
Your answer should be compact. 7.86e+1. In the year 2004, what is the difference between the Value added (constant 2005 US$) in Lower middle income and Value added (constant 2005 US$) in Jordan?
Offer a very short reply. 9.01e+11. In the year 2004, what is the difference between the Value added (constant 2005 US$) in Lower middle income and Value added (constant 2005 US$) in Slovenia?
Your response must be concise. 8.88e+11. In the year 2004, what is the difference between the Value added (constant 2005 US$) of Jordan and Value added (constant 2005 US$) of Slovenia?
Your answer should be compact. -1.23e+1. In the year 2005, what is the difference between the Value added (constant 2005 US$) in Heavily indebted poor countries and Value added (constant 2005 US$) in Lower middle income?
Provide a short and direct response. -8.79e+11. In the year 2005, what is the difference between the Value added (constant 2005 US$) of Heavily indebted poor countries and Value added (constant 2005 US$) of Jordan?
Your answer should be compact. 9.70e+1. In the year 2005, what is the difference between the Value added (constant 2005 US$) in Heavily indebted poor countries and Value added (constant 2005 US$) in Slovenia?
Your answer should be very brief. 8.44e+1. In the year 2005, what is the difference between the Value added (constant 2005 US$) of Lower middle income and Value added (constant 2005 US$) of Jordan?
Ensure brevity in your answer.  9.76e+11. In the year 2005, what is the difference between the Value added (constant 2005 US$) of Lower middle income and Value added (constant 2005 US$) of Slovenia?
Offer a very short reply. 9.63e+11. In the year 2005, what is the difference between the Value added (constant 2005 US$) in Jordan and Value added (constant 2005 US$) in Slovenia?
Keep it short and to the point. -1.26e+1. What is the ratio of the Value added (constant 2005 US$) in Heavily indebted poor countries in 1999 to that in 2000?
Your answer should be compact. 0.97. What is the ratio of the Value added (constant 2005 US$) in Lower middle income in 1999 to that in 2000?
Your answer should be compact. 0.95. What is the ratio of the Value added (constant 2005 US$) of Jordan in 1999 to that in 2000?
Provide a succinct answer. 0.95. What is the ratio of the Value added (constant 2005 US$) in Slovenia in 1999 to that in 2000?
Ensure brevity in your answer.  0.96. What is the ratio of the Value added (constant 2005 US$) in Heavily indebted poor countries in 1999 to that in 2001?
Your answer should be compact. 0.92. What is the ratio of the Value added (constant 2005 US$) of Lower middle income in 1999 to that in 2001?
Your response must be concise. 0.91. What is the ratio of the Value added (constant 2005 US$) in Jordan in 1999 to that in 2001?
Your answer should be compact. 0.91. What is the ratio of the Value added (constant 2005 US$) in Slovenia in 1999 to that in 2001?
Your response must be concise. 0.92. What is the ratio of the Value added (constant 2005 US$) of Heavily indebted poor countries in 1999 to that in 2002?
Keep it short and to the point. 0.88. What is the ratio of the Value added (constant 2005 US$) of Lower middle income in 1999 to that in 2002?
Your answer should be compact. 0.86. What is the ratio of the Value added (constant 2005 US$) of Jordan in 1999 to that in 2002?
Provide a short and direct response. 0.89. What is the ratio of the Value added (constant 2005 US$) in Slovenia in 1999 to that in 2002?
Your answer should be very brief. 0.89. What is the ratio of the Value added (constant 2005 US$) in Heavily indebted poor countries in 1999 to that in 2003?
Ensure brevity in your answer.  0.82. What is the ratio of the Value added (constant 2005 US$) of Lower middle income in 1999 to that in 2003?
Provide a short and direct response. 0.8. What is the ratio of the Value added (constant 2005 US$) of Jordan in 1999 to that in 2003?
Your answer should be compact. 0.85. What is the ratio of the Value added (constant 2005 US$) of Slovenia in 1999 to that in 2003?
Offer a very short reply. 0.86. What is the ratio of the Value added (constant 2005 US$) of Heavily indebted poor countries in 1999 to that in 2004?
Make the answer very short. 0.77. What is the ratio of the Value added (constant 2005 US$) in Lower middle income in 1999 to that in 2004?
Ensure brevity in your answer.  0.75. What is the ratio of the Value added (constant 2005 US$) in Jordan in 1999 to that in 2004?
Ensure brevity in your answer.  0.79. What is the ratio of the Value added (constant 2005 US$) in Slovenia in 1999 to that in 2004?
Offer a terse response. 0.83. What is the ratio of the Value added (constant 2005 US$) in Heavily indebted poor countries in 1999 to that in 2005?
Ensure brevity in your answer.  0.72. What is the ratio of the Value added (constant 2005 US$) in Lower middle income in 1999 to that in 2005?
Offer a very short reply. 0.69. What is the ratio of the Value added (constant 2005 US$) in Jordan in 1999 to that in 2005?
Your answer should be very brief. 0.73. What is the ratio of the Value added (constant 2005 US$) in Slovenia in 1999 to that in 2005?
Provide a succinct answer. 0.8. What is the ratio of the Value added (constant 2005 US$) in Heavily indebted poor countries in 2000 to that in 2001?
Your answer should be compact. 0.95. What is the ratio of the Value added (constant 2005 US$) in Lower middle income in 2000 to that in 2001?
Keep it short and to the point. 0.95. What is the ratio of the Value added (constant 2005 US$) in Jordan in 2000 to that in 2001?
Your response must be concise. 0.95. What is the ratio of the Value added (constant 2005 US$) in Slovenia in 2000 to that in 2001?
Your response must be concise. 0.96. What is the ratio of the Value added (constant 2005 US$) in Heavily indebted poor countries in 2000 to that in 2002?
Keep it short and to the point. 0.9. What is the ratio of the Value added (constant 2005 US$) in Lower middle income in 2000 to that in 2002?
Offer a very short reply. 0.9. What is the ratio of the Value added (constant 2005 US$) in Jordan in 2000 to that in 2002?
Offer a terse response. 0.93. What is the ratio of the Value added (constant 2005 US$) in Slovenia in 2000 to that in 2002?
Your answer should be very brief. 0.93. What is the ratio of the Value added (constant 2005 US$) in Heavily indebted poor countries in 2000 to that in 2003?
Give a very brief answer. 0.85. What is the ratio of the Value added (constant 2005 US$) of Lower middle income in 2000 to that in 2003?
Give a very brief answer. 0.84. What is the ratio of the Value added (constant 2005 US$) of Jordan in 2000 to that in 2003?
Your answer should be compact. 0.89. What is the ratio of the Value added (constant 2005 US$) of Slovenia in 2000 to that in 2003?
Ensure brevity in your answer.  0.9. What is the ratio of the Value added (constant 2005 US$) in Heavily indebted poor countries in 2000 to that in 2004?
Offer a very short reply. 0.79. What is the ratio of the Value added (constant 2005 US$) of Lower middle income in 2000 to that in 2004?
Keep it short and to the point. 0.78. What is the ratio of the Value added (constant 2005 US$) in Jordan in 2000 to that in 2004?
Offer a terse response. 0.83. What is the ratio of the Value added (constant 2005 US$) in Slovenia in 2000 to that in 2004?
Give a very brief answer. 0.86. What is the ratio of the Value added (constant 2005 US$) of Heavily indebted poor countries in 2000 to that in 2005?
Your response must be concise. 0.74. What is the ratio of the Value added (constant 2005 US$) in Lower middle income in 2000 to that in 2005?
Offer a very short reply. 0.72. What is the ratio of the Value added (constant 2005 US$) of Jordan in 2000 to that in 2005?
Ensure brevity in your answer.  0.77. What is the ratio of the Value added (constant 2005 US$) of Slovenia in 2000 to that in 2005?
Make the answer very short. 0.83. What is the ratio of the Value added (constant 2005 US$) of Heavily indebted poor countries in 2001 to that in 2002?
Provide a short and direct response. 0.95. What is the ratio of the Value added (constant 2005 US$) of Lower middle income in 2001 to that in 2002?
Offer a terse response. 0.95. What is the ratio of the Value added (constant 2005 US$) of Jordan in 2001 to that in 2002?
Ensure brevity in your answer.  0.98. What is the ratio of the Value added (constant 2005 US$) in Slovenia in 2001 to that in 2002?
Provide a short and direct response. 0.97. What is the ratio of the Value added (constant 2005 US$) of Heavily indebted poor countries in 2001 to that in 2003?
Make the answer very short. 0.89. What is the ratio of the Value added (constant 2005 US$) in Lower middle income in 2001 to that in 2003?
Provide a succinct answer. 0.89. What is the ratio of the Value added (constant 2005 US$) in Jordan in 2001 to that in 2003?
Give a very brief answer. 0.93. What is the ratio of the Value added (constant 2005 US$) in Slovenia in 2001 to that in 2003?
Ensure brevity in your answer.  0.93. What is the ratio of the Value added (constant 2005 US$) in Heavily indebted poor countries in 2001 to that in 2004?
Offer a terse response. 0.84. What is the ratio of the Value added (constant 2005 US$) of Lower middle income in 2001 to that in 2004?
Your answer should be very brief. 0.82. What is the ratio of the Value added (constant 2005 US$) of Jordan in 2001 to that in 2004?
Make the answer very short. 0.87. What is the ratio of the Value added (constant 2005 US$) of Slovenia in 2001 to that in 2004?
Make the answer very short. 0.9. What is the ratio of the Value added (constant 2005 US$) in Heavily indebted poor countries in 2001 to that in 2005?
Offer a terse response. 0.78. What is the ratio of the Value added (constant 2005 US$) of Lower middle income in 2001 to that in 2005?
Keep it short and to the point. 0.76. What is the ratio of the Value added (constant 2005 US$) in Jordan in 2001 to that in 2005?
Ensure brevity in your answer.  0.81. What is the ratio of the Value added (constant 2005 US$) in Slovenia in 2001 to that in 2005?
Ensure brevity in your answer.  0.86. What is the ratio of the Value added (constant 2005 US$) in Heavily indebted poor countries in 2002 to that in 2003?
Give a very brief answer. 0.94. What is the ratio of the Value added (constant 2005 US$) of Lower middle income in 2002 to that in 2003?
Offer a terse response. 0.94. What is the ratio of the Value added (constant 2005 US$) of Jordan in 2002 to that in 2003?
Keep it short and to the point. 0.95. What is the ratio of the Value added (constant 2005 US$) of Slovenia in 2002 to that in 2003?
Provide a succinct answer. 0.97. What is the ratio of the Value added (constant 2005 US$) in Heavily indebted poor countries in 2002 to that in 2004?
Give a very brief answer. 0.88. What is the ratio of the Value added (constant 2005 US$) of Lower middle income in 2002 to that in 2004?
Provide a short and direct response. 0.87. What is the ratio of the Value added (constant 2005 US$) in Jordan in 2002 to that in 2004?
Offer a very short reply. 0.89. What is the ratio of the Value added (constant 2005 US$) in Slovenia in 2002 to that in 2004?
Provide a short and direct response. 0.93. What is the ratio of the Value added (constant 2005 US$) of Heavily indebted poor countries in 2002 to that in 2005?
Your answer should be very brief. 0.82. What is the ratio of the Value added (constant 2005 US$) in Lower middle income in 2002 to that in 2005?
Your answer should be very brief. 0.8. What is the ratio of the Value added (constant 2005 US$) in Jordan in 2002 to that in 2005?
Offer a terse response. 0.83. What is the ratio of the Value added (constant 2005 US$) in Slovenia in 2002 to that in 2005?
Offer a terse response. 0.89. What is the ratio of the Value added (constant 2005 US$) of Heavily indebted poor countries in 2003 to that in 2004?
Your response must be concise. 0.94. What is the ratio of the Value added (constant 2005 US$) of Lower middle income in 2003 to that in 2004?
Keep it short and to the point. 0.93. What is the ratio of the Value added (constant 2005 US$) of Jordan in 2003 to that in 2004?
Provide a short and direct response. 0.94. What is the ratio of the Value added (constant 2005 US$) in Slovenia in 2003 to that in 2004?
Give a very brief answer. 0.96. What is the ratio of the Value added (constant 2005 US$) in Heavily indebted poor countries in 2003 to that in 2005?
Give a very brief answer. 0.88. What is the ratio of the Value added (constant 2005 US$) in Lower middle income in 2003 to that in 2005?
Keep it short and to the point. 0.85. What is the ratio of the Value added (constant 2005 US$) of Jordan in 2003 to that in 2005?
Keep it short and to the point. 0.87. What is the ratio of the Value added (constant 2005 US$) of Slovenia in 2003 to that in 2005?
Keep it short and to the point. 0.93. What is the ratio of the Value added (constant 2005 US$) of Heavily indebted poor countries in 2004 to that in 2005?
Provide a succinct answer. 0.94. What is the ratio of the Value added (constant 2005 US$) in Lower middle income in 2004 to that in 2005?
Offer a terse response. 0.92. What is the ratio of the Value added (constant 2005 US$) of Jordan in 2004 to that in 2005?
Your answer should be very brief. 0.92. What is the ratio of the Value added (constant 2005 US$) of Slovenia in 2004 to that in 2005?
Give a very brief answer. 0.96. What is the difference between the highest and the second highest Value added (constant 2005 US$) of Heavily indebted poor countries?
Offer a terse response. 6.63e+09. What is the difference between the highest and the second highest Value added (constant 2005 US$) of Lower middle income?
Give a very brief answer. 7.59e+1. What is the difference between the highest and the second highest Value added (constant 2005 US$) of Jordan?
Your answer should be compact. 5.85e+08. What is the difference between the highest and the second highest Value added (constant 2005 US$) in Slovenia?
Your response must be concise. 8.23e+08. What is the difference between the highest and the lowest Value added (constant 2005 US$) in Heavily indebted poor countries?
Offer a very short reply. 2.94e+1. What is the difference between the highest and the lowest Value added (constant 2005 US$) of Lower middle income?
Provide a succinct answer. 3.07e+11. What is the difference between the highest and the lowest Value added (constant 2005 US$) in Jordan?
Make the answer very short. 2.05e+09. What is the difference between the highest and the lowest Value added (constant 2005 US$) in Slovenia?
Give a very brief answer. 4.13e+09. 